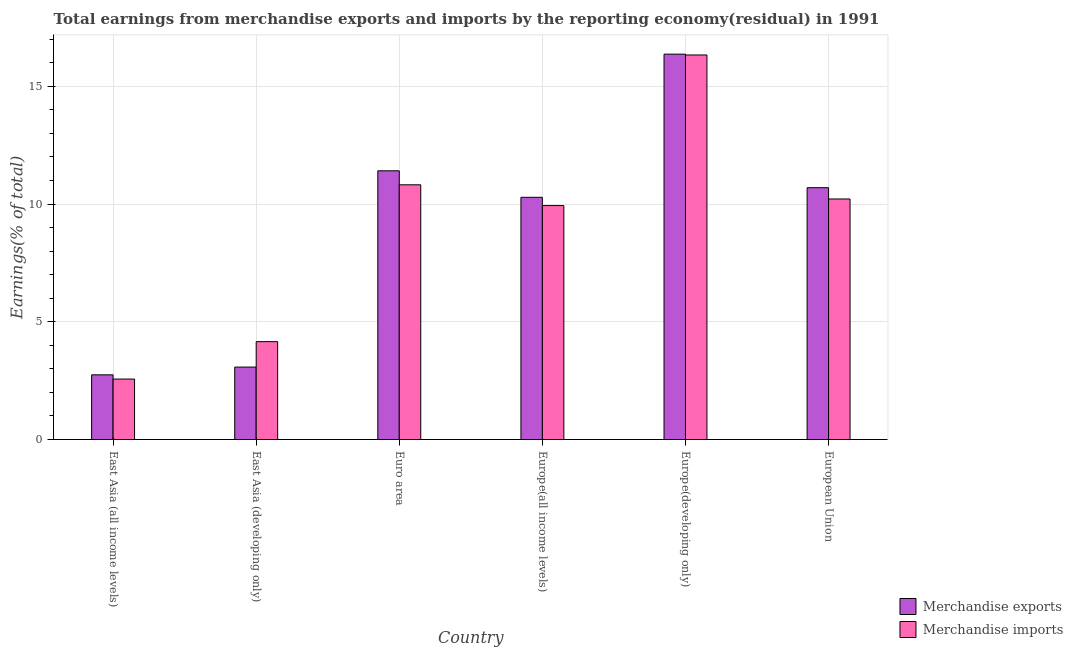How many different coloured bars are there?
Your answer should be very brief. 2. Are the number of bars per tick equal to the number of legend labels?
Provide a succinct answer. Yes. Are the number of bars on each tick of the X-axis equal?
Provide a short and direct response. Yes. How many bars are there on the 3rd tick from the right?
Keep it short and to the point. 2. What is the label of the 5th group of bars from the left?
Your answer should be very brief. Europe(developing only). What is the earnings from merchandise imports in East Asia (all income levels)?
Ensure brevity in your answer.  2.57. Across all countries, what is the maximum earnings from merchandise exports?
Provide a succinct answer. 16.37. Across all countries, what is the minimum earnings from merchandise exports?
Make the answer very short. 2.75. In which country was the earnings from merchandise imports maximum?
Provide a succinct answer. Europe(developing only). In which country was the earnings from merchandise exports minimum?
Provide a succinct answer. East Asia (all income levels). What is the total earnings from merchandise exports in the graph?
Offer a terse response. 54.58. What is the difference between the earnings from merchandise exports in East Asia (developing only) and that in Euro area?
Offer a very short reply. -8.34. What is the difference between the earnings from merchandise exports in Euro area and the earnings from merchandise imports in Europe(developing only)?
Give a very brief answer. -4.92. What is the average earnings from merchandise exports per country?
Your response must be concise. 9.1. What is the difference between the earnings from merchandise exports and earnings from merchandise imports in East Asia (developing only)?
Keep it short and to the point. -1.08. What is the ratio of the earnings from merchandise imports in East Asia (developing only) to that in European Union?
Your answer should be very brief. 0.41. Is the difference between the earnings from merchandise exports in Europe(developing only) and European Union greater than the difference between the earnings from merchandise imports in Europe(developing only) and European Union?
Keep it short and to the point. No. What is the difference between the highest and the second highest earnings from merchandise exports?
Give a very brief answer. 4.95. What is the difference between the highest and the lowest earnings from merchandise imports?
Ensure brevity in your answer.  13.76. In how many countries, is the earnings from merchandise exports greater than the average earnings from merchandise exports taken over all countries?
Offer a very short reply. 4. Is the sum of the earnings from merchandise exports in East Asia (all income levels) and East Asia (developing only) greater than the maximum earnings from merchandise imports across all countries?
Make the answer very short. No. What does the 2nd bar from the right in East Asia (all income levels) represents?
Your answer should be very brief. Merchandise exports. Are all the bars in the graph horizontal?
Offer a very short reply. No. What is the difference between two consecutive major ticks on the Y-axis?
Provide a short and direct response. 5. Are the values on the major ticks of Y-axis written in scientific E-notation?
Provide a succinct answer. No. Does the graph contain grids?
Provide a succinct answer. Yes. Where does the legend appear in the graph?
Ensure brevity in your answer.  Bottom right. What is the title of the graph?
Provide a short and direct response. Total earnings from merchandise exports and imports by the reporting economy(residual) in 1991. What is the label or title of the X-axis?
Ensure brevity in your answer.  Country. What is the label or title of the Y-axis?
Make the answer very short. Earnings(% of total). What is the Earnings(% of total) in Merchandise exports in East Asia (all income levels)?
Offer a terse response. 2.75. What is the Earnings(% of total) of Merchandise imports in East Asia (all income levels)?
Ensure brevity in your answer.  2.57. What is the Earnings(% of total) in Merchandise exports in East Asia (developing only)?
Offer a terse response. 3.08. What is the Earnings(% of total) in Merchandise imports in East Asia (developing only)?
Give a very brief answer. 4.16. What is the Earnings(% of total) of Merchandise exports in Euro area?
Offer a very short reply. 11.41. What is the Earnings(% of total) in Merchandise imports in Euro area?
Give a very brief answer. 10.82. What is the Earnings(% of total) in Merchandise exports in Europe(all income levels)?
Your response must be concise. 10.29. What is the Earnings(% of total) in Merchandise imports in Europe(all income levels)?
Give a very brief answer. 9.93. What is the Earnings(% of total) in Merchandise exports in Europe(developing only)?
Your answer should be very brief. 16.37. What is the Earnings(% of total) in Merchandise imports in Europe(developing only)?
Your response must be concise. 16.33. What is the Earnings(% of total) of Merchandise exports in European Union?
Offer a very short reply. 10.7. What is the Earnings(% of total) of Merchandise imports in European Union?
Your answer should be very brief. 10.22. Across all countries, what is the maximum Earnings(% of total) of Merchandise exports?
Make the answer very short. 16.37. Across all countries, what is the maximum Earnings(% of total) in Merchandise imports?
Offer a terse response. 16.33. Across all countries, what is the minimum Earnings(% of total) in Merchandise exports?
Offer a terse response. 2.75. Across all countries, what is the minimum Earnings(% of total) in Merchandise imports?
Offer a very short reply. 2.57. What is the total Earnings(% of total) of Merchandise exports in the graph?
Provide a short and direct response. 54.58. What is the total Earnings(% of total) of Merchandise imports in the graph?
Your response must be concise. 54.03. What is the difference between the Earnings(% of total) of Merchandise exports in East Asia (all income levels) and that in East Asia (developing only)?
Your answer should be compact. -0.33. What is the difference between the Earnings(% of total) of Merchandise imports in East Asia (all income levels) and that in East Asia (developing only)?
Make the answer very short. -1.59. What is the difference between the Earnings(% of total) in Merchandise exports in East Asia (all income levels) and that in Euro area?
Your answer should be very brief. -8.67. What is the difference between the Earnings(% of total) in Merchandise imports in East Asia (all income levels) and that in Euro area?
Provide a short and direct response. -8.25. What is the difference between the Earnings(% of total) of Merchandise exports in East Asia (all income levels) and that in Europe(all income levels)?
Your answer should be compact. -7.54. What is the difference between the Earnings(% of total) of Merchandise imports in East Asia (all income levels) and that in Europe(all income levels)?
Your answer should be very brief. -7.37. What is the difference between the Earnings(% of total) of Merchandise exports in East Asia (all income levels) and that in Europe(developing only)?
Provide a short and direct response. -13.62. What is the difference between the Earnings(% of total) in Merchandise imports in East Asia (all income levels) and that in Europe(developing only)?
Give a very brief answer. -13.76. What is the difference between the Earnings(% of total) in Merchandise exports in East Asia (all income levels) and that in European Union?
Provide a short and direct response. -7.95. What is the difference between the Earnings(% of total) of Merchandise imports in East Asia (all income levels) and that in European Union?
Offer a terse response. -7.65. What is the difference between the Earnings(% of total) of Merchandise exports in East Asia (developing only) and that in Euro area?
Ensure brevity in your answer.  -8.34. What is the difference between the Earnings(% of total) of Merchandise imports in East Asia (developing only) and that in Euro area?
Offer a very short reply. -6.66. What is the difference between the Earnings(% of total) in Merchandise exports in East Asia (developing only) and that in Europe(all income levels)?
Make the answer very short. -7.21. What is the difference between the Earnings(% of total) in Merchandise imports in East Asia (developing only) and that in Europe(all income levels)?
Provide a short and direct response. -5.78. What is the difference between the Earnings(% of total) in Merchandise exports in East Asia (developing only) and that in Europe(developing only)?
Your response must be concise. -13.29. What is the difference between the Earnings(% of total) in Merchandise imports in East Asia (developing only) and that in Europe(developing only)?
Your answer should be very brief. -12.18. What is the difference between the Earnings(% of total) in Merchandise exports in East Asia (developing only) and that in European Union?
Give a very brief answer. -7.62. What is the difference between the Earnings(% of total) of Merchandise imports in East Asia (developing only) and that in European Union?
Offer a terse response. -6.06. What is the difference between the Earnings(% of total) of Merchandise exports in Euro area and that in Europe(all income levels)?
Keep it short and to the point. 1.13. What is the difference between the Earnings(% of total) in Merchandise imports in Euro area and that in Europe(all income levels)?
Provide a succinct answer. 0.88. What is the difference between the Earnings(% of total) in Merchandise exports in Euro area and that in Europe(developing only)?
Offer a terse response. -4.95. What is the difference between the Earnings(% of total) in Merchandise imports in Euro area and that in Europe(developing only)?
Your answer should be very brief. -5.51. What is the difference between the Earnings(% of total) in Merchandise exports in Euro area and that in European Union?
Offer a terse response. 0.72. What is the difference between the Earnings(% of total) of Merchandise imports in Euro area and that in European Union?
Ensure brevity in your answer.  0.6. What is the difference between the Earnings(% of total) of Merchandise exports in Europe(all income levels) and that in Europe(developing only)?
Offer a very short reply. -6.08. What is the difference between the Earnings(% of total) in Merchandise imports in Europe(all income levels) and that in Europe(developing only)?
Provide a short and direct response. -6.4. What is the difference between the Earnings(% of total) of Merchandise exports in Europe(all income levels) and that in European Union?
Offer a very short reply. -0.41. What is the difference between the Earnings(% of total) in Merchandise imports in Europe(all income levels) and that in European Union?
Your answer should be compact. -0.28. What is the difference between the Earnings(% of total) of Merchandise exports in Europe(developing only) and that in European Union?
Offer a very short reply. 5.67. What is the difference between the Earnings(% of total) in Merchandise imports in Europe(developing only) and that in European Union?
Keep it short and to the point. 6.12. What is the difference between the Earnings(% of total) in Merchandise exports in East Asia (all income levels) and the Earnings(% of total) in Merchandise imports in East Asia (developing only)?
Make the answer very short. -1.41. What is the difference between the Earnings(% of total) in Merchandise exports in East Asia (all income levels) and the Earnings(% of total) in Merchandise imports in Euro area?
Ensure brevity in your answer.  -8.07. What is the difference between the Earnings(% of total) in Merchandise exports in East Asia (all income levels) and the Earnings(% of total) in Merchandise imports in Europe(all income levels)?
Provide a short and direct response. -7.19. What is the difference between the Earnings(% of total) in Merchandise exports in East Asia (all income levels) and the Earnings(% of total) in Merchandise imports in Europe(developing only)?
Give a very brief answer. -13.59. What is the difference between the Earnings(% of total) of Merchandise exports in East Asia (all income levels) and the Earnings(% of total) of Merchandise imports in European Union?
Offer a terse response. -7.47. What is the difference between the Earnings(% of total) in Merchandise exports in East Asia (developing only) and the Earnings(% of total) in Merchandise imports in Euro area?
Your answer should be very brief. -7.74. What is the difference between the Earnings(% of total) of Merchandise exports in East Asia (developing only) and the Earnings(% of total) of Merchandise imports in Europe(all income levels)?
Keep it short and to the point. -6.86. What is the difference between the Earnings(% of total) of Merchandise exports in East Asia (developing only) and the Earnings(% of total) of Merchandise imports in Europe(developing only)?
Keep it short and to the point. -13.26. What is the difference between the Earnings(% of total) of Merchandise exports in East Asia (developing only) and the Earnings(% of total) of Merchandise imports in European Union?
Keep it short and to the point. -7.14. What is the difference between the Earnings(% of total) of Merchandise exports in Euro area and the Earnings(% of total) of Merchandise imports in Europe(all income levels)?
Provide a short and direct response. 1.48. What is the difference between the Earnings(% of total) of Merchandise exports in Euro area and the Earnings(% of total) of Merchandise imports in Europe(developing only)?
Provide a short and direct response. -4.92. What is the difference between the Earnings(% of total) in Merchandise exports in Euro area and the Earnings(% of total) in Merchandise imports in European Union?
Your answer should be very brief. 1.2. What is the difference between the Earnings(% of total) in Merchandise exports in Europe(all income levels) and the Earnings(% of total) in Merchandise imports in Europe(developing only)?
Give a very brief answer. -6.05. What is the difference between the Earnings(% of total) of Merchandise exports in Europe(all income levels) and the Earnings(% of total) of Merchandise imports in European Union?
Ensure brevity in your answer.  0.07. What is the difference between the Earnings(% of total) of Merchandise exports in Europe(developing only) and the Earnings(% of total) of Merchandise imports in European Union?
Ensure brevity in your answer.  6.15. What is the average Earnings(% of total) in Merchandise exports per country?
Keep it short and to the point. 9.1. What is the average Earnings(% of total) of Merchandise imports per country?
Ensure brevity in your answer.  9. What is the difference between the Earnings(% of total) in Merchandise exports and Earnings(% of total) in Merchandise imports in East Asia (all income levels)?
Provide a succinct answer. 0.18. What is the difference between the Earnings(% of total) in Merchandise exports and Earnings(% of total) in Merchandise imports in East Asia (developing only)?
Keep it short and to the point. -1.08. What is the difference between the Earnings(% of total) of Merchandise exports and Earnings(% of total) of Merchandise imports in Euro area?
Your answer should be very brief. 0.59. What is the difference between the Earnings(% of total) in Merchandise exports and Earnings(% of total) in Merchandise imports in Europe(all income levels)?
Offer a terse response. 0.35. What is the difference between the Earnings(% of total) in Merchandise exports and Earnings(% of total) in Merchandise imports in Europe(developing only)?
Provide a short and direct response. 0.03. What is the difference between the Earnings(% of total) in Merchandise exports and Earnings(% of total) in Merchandise imports in European Union?
Keep it short and to the point. 0.48. What is the ratio of the Earnings(% of total) in Merchandise exports in East Asia (all income levels) to that in East Asia (developing only)?
Provide a short and direct response. 0.89. What is the ratio of the Earnings(% of total) in Merchandise imports in East Asia (all income levels) to that in East Asia (developing only)?
Your response must be concise. 0.62. What is the ratio of the Earnings(% of total) in Merchandise exports in East Asia (all income levels) to that in Euro area?
Offer a very short reply. 0.24. What is the ratio of the Earnings(% of total) of Merchandise imports in East Asia (all income levels) to that in Euro area?
Ensure brevity in your answer.  0.24. What is the ratio of the Earnings(% of total) of Merchandise exports in East Asia (all income levels) to that in Europe(all income levels)?
Ensure brevity in your answer.  0.27. What is the ratio of the Earnings(% of total) of Merchandise imports in East Asia (all income levels) to that in Europe(all income levels)?
Give a very brief answer. 0.26. What is the ratio of the Earnings(% of total) of Merchandise exports in East Asia (all income levels) to that in Europe(developing only)?
Your answer should be very brief. 0.17. What is the ratio of the Earnings(% of total) of Merchandise imports in East Asia (all income levels) to that in Europe(developing only)?
Offer a very short reply. 0.16. What is the ratio of the Earnings(% of total) of Merchandise exports in East Asia (all income levels) to that in European Union?
Offer a very short reply. 0.26. What is the ratio of the Earnings(% of total) in Merchandise imports in East Asia (all income levels) to that in European Union?
Provide a succinct answer. 0.25. What is the ratio of the Earnings(% of total) of Merchandise exports in East Asia (developing only) to that in Euro area?
Offer a very short reply. 0.27. What is the ratio of the Earnings(% of total) of Merchandise imports in East Asia (developing only) to that in Euro area?
Provide a short and direct response. 0.38. What is the ratio of the Earnings(% of total) in Merchandise exports in East Asia (developing only) to that in Europe(all income levels)?
Offer a terse response. 0.3. What is the ratio of the Earnings(% of total) in Merchandise imports in East Asia (developing only) to that in Europe(all income levels)?
Keep it short and to the point. 0.42. What is the ratio of the Earnings(% of total) in Merchandise exports in East Asia (developing only) to that in Europe(developing only)?
Offer a terse response. 0.19. What is the ratio of the Earnings(% of total) of Merchandise imports in East Asia (developing only) to that in Europe(developing only)?
Make the answer very short. 0.25. What is the ratio of the Earnings(% of total) of Merchandise exports in East Asia (developing only) to that in European Union?
Offer a terse response. 0.29. What is the ratio of the Earnings(% of total) in Merchandise imports in East Asia (developing only) to that in European Union?
Ensure brevity in your answer.  0.41. What is the ratio of the Earnings(% of total) of Merchandise exports in Euro area to that in Europe(all income levels)?
Provide a succinct answer. 1.11. What is the ratio of the Earnings(% of total) in Merchandise imports in Euro area to that in Europe(all income levels)?
Provide a succinct answer. 1.09. What is the ratio of the Earnings(% of total) of Merchandise exports in Euro area to that in Europe(developing only)?
Your response must be concise. 0.7. What is the ratio of the Earnings(% of total) in Merchandise imports in Euro area to that in Europe(developing only)?
Give a very brief answer. 0.66. What is the ratio of the Earnings(% of total) in Merchandise exports in Euro area to that in European Union?
Offer a very short reply. 1.07. What is the ratio of the Earnings(% of total) of Merchandise imports in Euro area to that in European Union?
Ensure brevity in your answer.  1.06. What is the ratio of the Earnings(% of total) in Merchandise exports in Europe(all income levels) to that in Europe(developing only)?
Your answer should be compact. 0.63. What is the ratio of the Earnings(% of total) of Merchandise imports in Europe(all income levels) to that in Europe(developing only)?
Offer a very short reply. 0.61. What is the ratio of the Earnings(% of total) of Merchandise exports in Europe(all income levels) to that in European Union?
Your answer should be very brief. 0.96. What is the ratio of the Earnings(% of total) of Merchandise imports in Europe(all income levels) to that in European Union?
Provide a short and direct response. 0.97. What is the ratio of the Earnings(% of total) in Merchandise exports in Europe(developing only) to that in European Union?
Offer a very short reply. 1.53. What is the ratio of the Earnings(% of total) of Merchandise imports in Europe(developing only) to that in European Union?
Your answer should be very brief. 1.6. What is the difference between the highest and the second highest Earnings(% of total) of Merchandise exports?
Offer a very short reply. 4.95. What is the difference between the highest and the second highest Earnings(% of total) in Merchandise imports?
Offer a very short reply. 5.51. What is the difference between the highest and the lowest Earnings(% of total) of Merchandise exports?
Give a very brief answer. 13.62. What is the difference between the highest and the lowest Earnings(% of total) in Merchandise imports?
Your answer should be very brief. 13.76. 